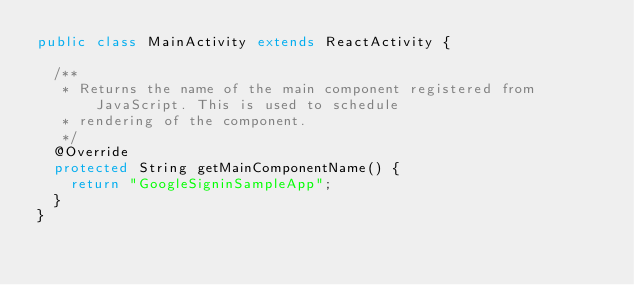<code> <loc_0><loc_0><loc_500><loc_500><_Java_>public class MainActivity extends ReactActivity {

  /**
   * Returns the name of the main component registered from JavaScript. This is used to schedule
   * rendering of the component.
   */
  @Override
  protected String getMainComponentName() {
    return "GoogleSigninSampleApp";
  }
}
</code> 